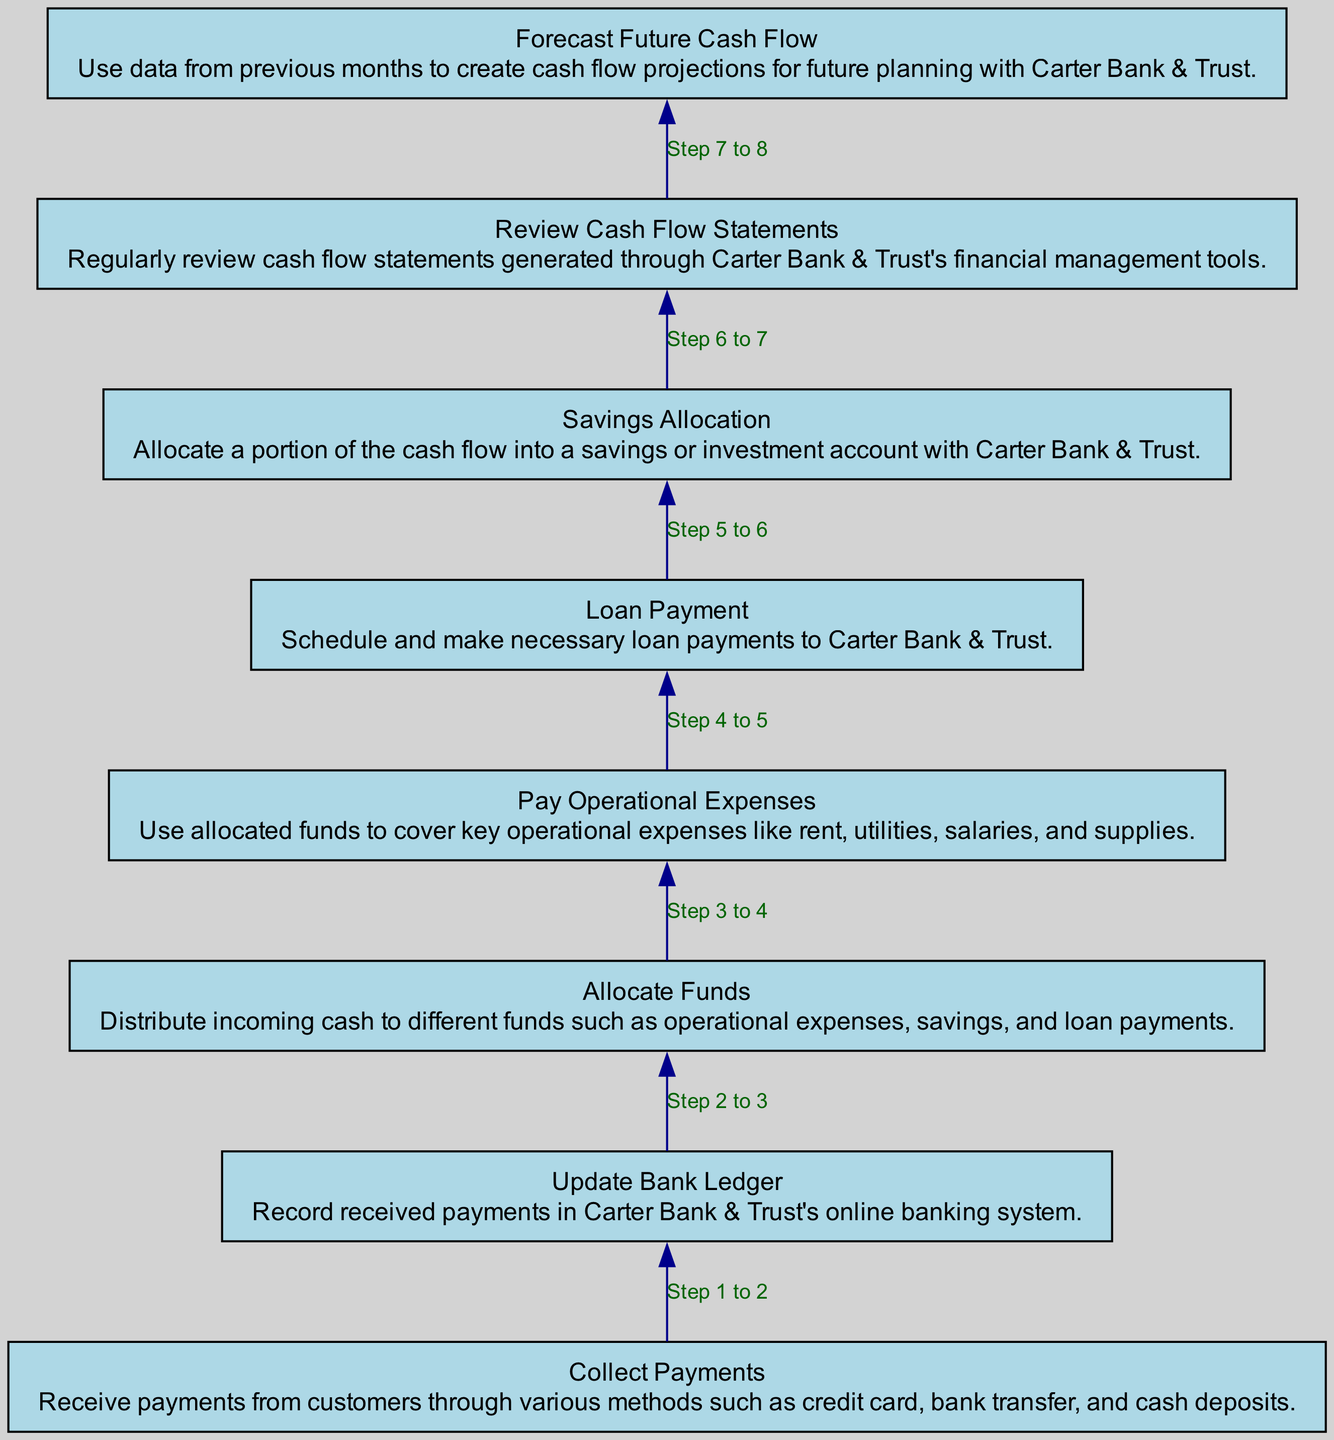What is the first step in the diagram? The flowchart begins with the first node labeled "Collect Payments," indicating that this is the initial action to be taken in the cash flow management process.
Answer: Collect Payments How many nodes are there in the diagram? The diagram contains a total of eight nodes, each representing a crucial step in monthly cash flow management.
Answer: 8 What is the last step mentioned in the diagram? The final node in the flowchart is "Forecast Future Cash Flow," suggesting that this is the concluding action in the cash flow management process.
Answer: Forecast Future Cash Flow Which step directly follows "Update Bank Ledger"? Following "Update Bank Ledger," the next step in the sequence is "Allocate Funds," indicating the progression from updating records to distributing received payments.
Answer: Allocate Funds What is the relationship between "Savings Allocation" and "Loan Payment"? "Savings Allocation" and "Loan Payment" are sequential steps in the flowchart, with "Savings Allocation" being executed after "Pay Operational Expenses," but they do not directly connect to each other in the order of operations shown.
Answer: No direct relationship 